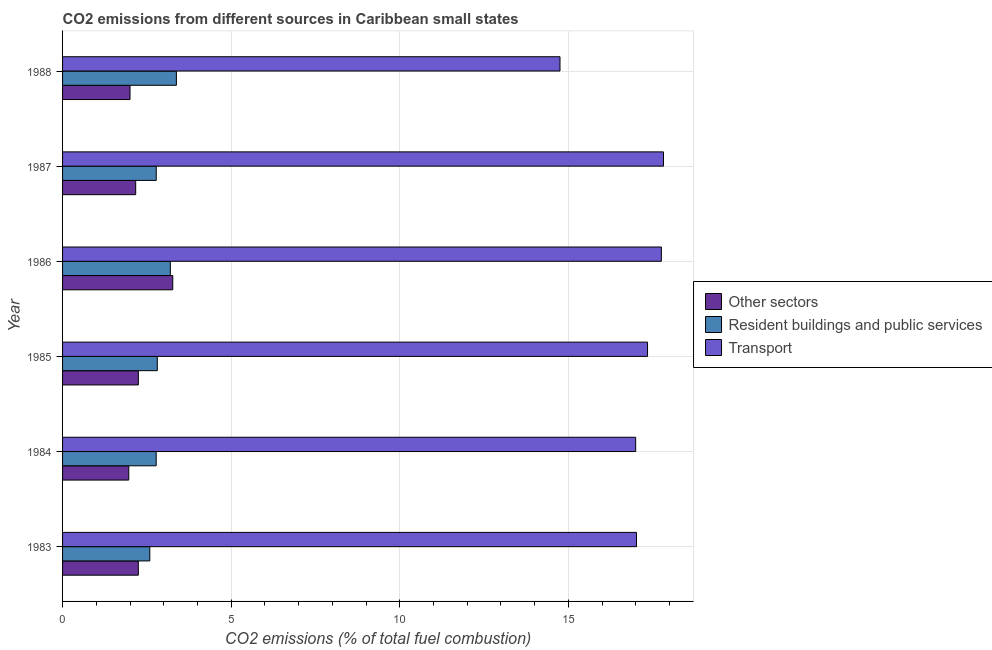How many groups of bars are there?
Your answer should be compact. 6. Are the number of bars per tick equal to the number of legend labels?
Provide a short and direct response. Yes. Are the number of bars on each tick of the Y-axis equal?
Keep it short and to the point. Yes. How many bars are there on the 2nd tick from the top?
Keep it short and to the point. 3. What is the percentage of co2 emissions from transport in 1988?
Your response must be concise. 14.75. Across all years, what is the maximum percentage of co2 emissions from other sectors?
Make the answer very short. 3.27. Across all years, what is the minimum percentage of co2 emissions from other sectors?
Make the answer very short. 1.96. In which year was the percentage of co2 emissions from resident buildings and public services maximum?
Your answer should be very brief. 1988. What is the total percentage of co2 emissions from other sectors in the graph?
Offer a very short reply. 13.89. What is the difference between the percentage of co2 emissions from other sectors in 1983 and that in 1984?
Ensure brevity in your answer.  0.28. What is the difference between the percentage of co2 emissions from other sectors in 1988 and the percentage of co2 emissions from resident buildings and public services in 1983?
Provide a short and direct response. -0.59. What is the average percentage of co2 emissions from other sectors per year?
Offer a terse response. 2.31. In the year 1988, what is the difference between the percentage of co2 emissions from resident buildings and public services and percentage of co2 emissions from transport?
Your answer should be very brief. -11.38. What is the ratio of the percentage of co2 emissions from resident buildings and public services in 1983 to that in 1988?
Give a very brief answer. 0.77. Is the percentage of co2 emissions from other sectors in 1983 less than that in 1986?
Offer a terse response. Yes. Is the difference between the percentage of co2 emissions from resident buildings and public services in 1983 and 1985 greater than the difference between the percentage of co2 emissions from other sectors in 1983 and 1985?
Provide a succinct answer. No. What is the difference between the highest and the second highest percentage of co2 emissions from resident buildings and public services?
Provide a short and direct response. 0.18. What does the 3rd bar from the top in 1984 represents?
Your answer should be very brief. Other sectors. What does the 1st bar from the bottom in 1986 represents?
Your answer should be very brief. Other sectors. Is it the case that in every year, the sum of the percentage of co2 emissions from other sectors and percentage of co2 emissions from resident buildings and public services is greater than the percentage of co2 emissions from transport?
Ensure brevity in your answer.  No. How many bars are there?
Your answer should be compact. 18. Are all the bars in the graph horizontal?
Your answer should be compact. Yes. What is the difference between two consecutive major ticks on the X-axis?
Your response must be concise. 5. How are the legend labels stacked?
Keep it short and to the point. Vertical. What is the title of the graph?
Offer a very short reply. CO2 emissions from different sources in Caribbean small states. Does "Ages 0-14" appear as one of the legend labels in the graph?
Your response must be concise. No. What is the label or title of the X-axis?
Give a very brief answer. CO2 emissions (% of total fuel combustion). What is the CO2 emissions (% of total fuel combustion) of Other sectors in 1983?
Provide a succinct answer. 2.25. What is the CO2 emissions (% of total fuel combustion) in Resident buildings and public services in 1983?
Your response must be concise. 2.59. What is the CO2 emissions (% of total fuel combustion) in Transport in 1983?
Provide a short and direct response. 17.02. What is the CO2 emissions (% of total fuel combustion) in Other sectors in 1984?
Your response must be concise. 1.96. What is the CO2 emissions (% of total fuel combustion) in Resident buildings and public services in 1984?
Make the answer very short. 2.78. What is the CO2 emissions (% of total fuel combustion) in Transport in 1984?
Provide a succinct answer. 16.99. What is the CO2 emissions (% of total fuel combustion) in Other sectors in 1985?
Give a very brief answer. 2.25. What is the CO2 emissions (% of total fuel combustion) in Resident buildings and public services in 1985?
Provide a succinct answer. 2.81. What is the CO2 emissions (% of total fuel combustion) in Transport in 1985?
Provide a succinct answer. 17.35. What is the CO2 emissions (% of total fuel combustion) of Other sectors in 1986?
Your answer should be compact. 3.27. What is the CO2 emissions (% of total fuel combustion) of Resident buildings and public services in 1986?
Ensure brevity in your answer.  3.2. What is the CO2 emissions (% of total fuel combustion) in Transport in 1986?
Your answer should be very brief. 17.76. What is the CO2 emissions (% of total fuel combustion) of Other sectors in 1987?
Make the answer very short. 2.17. What is the CO2 emissions (% of total fuel combustion) in Resident buildings and public services in 1987?
Keep it short and to the point. 2.78. What is the CO2 emissions (% of total fuel combustion) in Transport in 1987?
Keep it short and to the point. 17.82. What is the CO2 emissions (% of total fuel combustion) in Resident buildings and public services in 1988?
Your response must be concise. 3.38. What is the CO2 emissions (% of total fuel combustion) in Transport in 1988?
Offer a very short reply. 14.75. Across all years, what is the maximum CO2 emissions (% of total fuel combustion) in Other sectors?
Your answer should be compact. 3.27. Across all years, what is the maximum CO2 emissions (% of total fuel combustion) of Resident buildings and public services?
Provide a short and direct response. 3.38. Across all years, what is the maximum CO2 emissions (% of total fuel combustion) in Transport?
Your answer should be compact. 17.82. Across all years, what is the minimum CO2 emissions (% of total fuel combustion) of Other sectors?
Offer a very short reply. 1.96. Across all years, what is the minimum CO2 emissions (% of total fuel combustion) of Resident buildings and public services?
Your response must be concise. 2.59. Across all years, what is the minimum CO2 emissions (% of total fuel combustion) of Transport?
Give a very brief answer. 14.75. What is the total CO2 emissions (% of total fuel combustion) of Other sectors in the graph?
Provide a short and direct response. 13.89. What is the total CO2 emissions (% of total fuel combustion) of Resident buildings and public services in the graph?
Your response must be concise. 17.52. What is the total CO2 emissions (% of total fuel combustion) in Transport in the graph?
Offer a very short reply. 101.68. What is the difference between the CO2 emissions (% of total fuel combustion) of Other sectors in 1983 and that in 1984?
Offer a very short reply. 0.28. What is the difference between the CO2 emissions (% of total fuel combustion) in Resident buildings and public services in 1983 and that in 1984?
Offer a terse response. -0.19. What is the difference between the CO2 emissions (% of total fuel combustion) in Transport in 1983 and that in 1984?
Give a very brief answer. 0.02. What is the difference between the CO2 emissions (% of total fuel combustion) of Other sectors in 1983 and that in 1985?
Provide a succinct answer. -0. What is the difference between the CO2 emissions (% of total fuel combustion) of Resident buildings and public services in 1983 and that in 1985?
Give a very brief answer. -0.22. What is the difference between the CO2 emissions (% of total fuel combustion) in Transport in 1983 and that in 1985?
Provide a short and direct response. -0.33. What is the difference between the CO2 emissions (% of total fuel combustion) of Other sectors in 1983 and that in 1986?
Ensure brevity in your answer.  -1.02. What is the difference between the CO2 emissions (% of total fuel combustion) of Resident buildings and public services in 1983 and that in 1986?
Offer a terse response. -0.61. What is the difference between the CO2 emissions (% of total fuel combustion) of Transport in 1983 and that in 1986?
Offer a terse response. -0.74. What is the difference between the CO2 emissions (% of total fuel combustion) in Other sectors in 1983 and that in 1987?
Your response must be concise. 0.08. What is the difference between the CO2 emissions (% of total fuel combustion) in Resident buildings and public services in 1983 and that in 1987?
Provide a succinct answer. -0.19. What is the difference between the CO2 emissions (% of total fuel combustion) of Other sectors in 1983 and that in 1988?
Keep it short and to the point. 0.25. What is the difference between the CO2 emissions (% of total fuel combustion) of Resident buildings and public services in 1983 and that in 1988?
Make the answer very short. -0.79. What is the difference between the CO2 emissions (% of total fuel combustion) in Transport in 1983 and that in 1988?
Your answer should be compact. 2.27. What is the difference between the CO2 emissions (% of total fuel combustion) of Other sectors in 1984 and that in 1985?
Offer a very short reply. -0.28. What is the difference between the CO2 emissions (% of total fuel combustion) of Resident buildings and public services in 1984 and that in 1985?
Offer a terse response. -0.03. What is the difference between the CO2 emissions (% of total fuel combustion) in Transport in 1984 and that in 1985?
Your answer should be compact. -0.35. What is the difference between the CO2 emissions (% of total fuel combustion) of Other sectors in 1984 and that in 1986?
Keep it short and to the point. -1.3. What is the difference between the CO2 emissions (% of total fuel combustion) of Resident buildings and public services in 1984 and that in 1986?
Make the answer very short. -0.42. What is the difference between the CO2 emissions (% of total fuel combustion) in Transport in 1984 and that in 1986?
Provide a short and direct response. -0.76. What is the difference between the CO2 emissions (% of total fuel combustion) of Other sectors in 1984 and that in 1987?
Give a very brief answer. -0.2. What is the difference between the CO2 emissions (% of total fuel combustion) in Resident buildings and public services in 1984 and that in 1987?
Provide a short and direct response. -0. What is the difference between the CO2 emissions (% of total fuel combustion) in Transport in 1984 and that in 1987?
Your answer should be compact. -0.82. What is the difference between the CO2 emissions (% of total fuel combustion) of Other sectors in 1984 and that in 1988?
Ensure brevity in your answer.  -0.04. What is the difference between the CO2 emissions (% of total fuel combustion) of Resident buildings and public services in 1984 and that in 1988?
Offer a very short reply. -0.6. What is the difference between the CO2 emissions (% of total fuel combustion) in Transport in 1984 and that in 1988?
Offer a very short reply. 2.24. What is the difference between the CO2 emissions (% of total fuel combustion) in Other sectors in 1985 and that in 1986?
Offer a terse response. -1.02. What is the difference between the CO2 emissions (% of total fuel combustion) of Resident buildings and public services in 1985 and that in 1986?
Provide a succinct answer. -0.39. What is the difference between the CO2 emissions (% of total fuel combustion) of Transport in 1985 and that in 1986?
Ensure brevity in your answer.  -0.41. What is the difference between the CO2 emissions (% of total fuel combustion) in Other sectors in 1985 and that in 1987?
Provide a succinct answer. 0.08. What is the difference between the CO2 emissions (% of total fuel combustion) of Resident buildings and public services in 1985 and that in 1987?
Make the answer very short. 0.03. What is the difference between the CO2 emissions (% of total fuel combustion) in Transport in 1985 and that in 1987?
Keep it short and to the point. -0.47. What is the difference between the CO2 emissions (% of total fuel combustion) of Other sectors in 1985 and that in 1988?
Provide a succinct answer. 0.25. What is the difference between the CO2 emissions (% of total fuel combustion) of Resident buildings and public services in 1985 and that in 1988?
Provide a succinct answer. -0.57. What is the difference between the CO2 emissions (% of total fuel combustion) of Transport in 1985 and that in 1988?
Offer a very short reply. 2.6. What is the difference between the CO2 emissions (% of total fuel combustion) in Other sectors in 1986 and that in 1987?
Provide a short and direct response. 1.1. What is the difference between the CO2 emissions (% of total fuel combustion) in Resident buildings and public services in 1986 and that in 1987?
Provide a short and direct response. 0.42. What is the difference between the CO2 emissions (% of total fuel combustion) in Transport in 1986 and that in 1987?
Offer a very short reply. -0.06. What is the difference between the CO2 emissions (% of total fuel combustion) in Other sectors in 1986 and that in 1988?
Offer a terse response. 1.27. What is the difference between the CO2 emissions (% of total fuel combustion) in Resident buildings and public services in 1986 and that in 1988?
Provide a short and direct response. -0.18. What is the difference between the CO2 emissions (% of total fuel combustion) in Transport in 1986 and that in 1988?
Make the answer very short. 3.01. What is the difference between the CO2 emissions (% of total fuel combustion) in Other sectors in 1987 and that in 1988?
Provide a succinct answer. 0.17. What is the difference between the CO2 emissions (% of total fuel combustion) in Resident buildings and public services in 1987 and that in 1988?
Keep it short and to the point. -0.6. What is the difference between the CO2 emissions (% of total fuel combustion) of Transport in 1987 and that in 1988?
Make the answer very short. 3.07. What is the difference between the CO2 emissions (% of total fuel combustion) in Other sectors in 1983 and the CO2 emissions (% of total fuel combustion) in Resident buildings and public services in 1984?
Provide a short and direct response. -0.53. What is the difference between the CO2 emissions (% of total fuel combustion) in Other sectors in 1983 and the CO2 emissions (% of total fuel combustion) in Transport in 1984?
Offer a terse response. -14.75. What is the difference between the CO2 emissions (% of total fuel combustion) of Resident buildings and public services in 1983 and the CO2 emissions (% of total fuel combustion) of Transport in 1984?
Your answer should be compact. -14.41. What is the difference between the CO2 emissions (% of total fuel combustion) of Other sectors in 1983 and the CO2 emissions (% of total fuel combustion) of Resident buildings and public services in 1985?
Your response must be concise. -0.56. What is the difference between the CO2 emissions (% of total fuel combustion) in Other sectors in 1983 and the CO2 emissions (% of total fuel combustion) in Transport in 1985?
Offer a terse response. -15.1. What is the difference between the CO2 emissions (% of total fuel combustion) of Resident buildings and public services in 1983 and the CO2 emissions (% of total fuel combustion) of Transport in 1985?
Offer a terse response. -14.76. What is the difference between the CO2 emissions (% of total fuel combustion) in Other sectors in 1983 and the CO2 emissions (% of total fuel combustion) in Resident buildings and public services in 1986?
Provide a succinct answer. -0.95. What is the difference between the CO2 emissions (% of total fuel combustion) of Other sectors in 1983 and the CO2 emissions (% of total fuel combustion) of Transport in 1986?
Offer a very short reply. -15.51. What is the difference between the CO2 emissions (% of total fuel combustion) of Resident buildings and public services in 1983 and the CO2 emissions (% of total fuel combustion) of Transport in 1986?
Give a very brief answer. -15.17. What is the difference between the CO2 emissions (% of total fuel combustion) of Other sectors in 1983 and the CO2 emissions (% of total fuel combustion) of Resident buildings and public services in 1987?
Give a very brief answer. -0.53. What is the difference between the CO2 emissions (% of total fuel combustion) in Other sectors in 1983 and the CO2 emissions (% of total fuel combustion) in Transport in 1987?
Keep it short and to the point. -15.57. What is the difference between the CO2 emissions (% of total fuel combustion) of Resident buildings and public services in 1983 and the CO2 emissions (% of total fuel combustion) of Transport in 1987?
Offer a very short reply. -15.23. What is the difference between the CO2 emissions (% of total fuel combustion) in Other sectors in 1983 and the CO2 emissions (% of total fuel combustion) in Resident buildings and public services in 1988?
Your answer should be compact. -1.13. What is the difference between the CO2 emissions (% of total fuel combustion) of Other sectors in 1983 and the CO2 emissions (% of total fuel combustion) of Transport in 1988?
Your answer should be compact. -12.5. What is the difference between the CO2 emissions (% of total fuel combustion) in Resident buildings and public services in 1983 and the CO2 emissions (% of total fuel combustion) in Transport in 1988?
Offer a terse response. -12.16. What is the difference between the CO2 emissions (% of total fuel combustion) of Other sectors in 1984 and the CO2 emissions (% of total fuel combustion) of Resident buildings and public services in 1985?
Make the answer very short. -0.85. What is the difference between the CO2 emissions (% of total fuel combustion) in Other sectors in 1984 and the CO2 emissions (% of total fuel combustion) in Transport in 1985?
Provide a short and direct response. -15.38. What is the difference between the CO2 emissions (% of total fuel combustion) in Resident buildings and public services in 1984 and the CO2 emissions (% of total fuel combustion) in Transport in 1985?
Your answer should be compact. -14.57. What is the difference between the CO2 emissions (% of total fuel combustion) of Other sectors in 1984 and the CO2 emissions (% of total fuel combustion) of Resident buildings and public services in 1986?
Your answer should be very brief. -1.23. What is the difference between the CO2 emissions (% of total fuel combustion) in Other sectors in 1984 and the CO2 emissions (% of total fuel combustion) in Transport in 1986?
Your answer should be compact. -15.79. What is the difference between the CO2 emissions (% of total fuel combustion) of Resident buildings and public services in 1984 and the CO2 emissions (% of total fuel combustion) of Transport in 1986?
Ensure brevity in your answer.  -14.98. What is the difference between the CO2 emissions (% of total fuel combustion) in Other sectors in 1984 and the CO2 emissions (% of total fuel combustion) in Resident buildings and public services in 1987?
Keep it short and to the point. -0.81. What is the difference between the CO2 emissions (% of total fuel combustion) in Other sectors in 1984 and the CO2 emissions (% of total fuel combustion) in Transport in 1987?
Give a very brief answer. -15.86. What is the difference between the CO2 emissions (% of total fuel combustion) in Resident buildings and public services in 1984 and the CO2 emissions (% of total fuel combustion) in Transport in 1987?
Provide a succinct answer. -15.04. What is the difference between the CO2 emissions (% of total fuel combustion) in Other sectors in 1984 and the CO2 emissions (% of total fuel combustion) in Resident buildings and public services in 1988?
Give a very brief answer. -1.41. What is the difference between the CO2 emissions (% of total fuel combustion) of Other sectors in 1984 and the CO2 emissions (% of total fuel combustion) of Transport in 1988?
Keep it short and to the point. -12.79. What is the difference between the CO2 emissions (% of total fuel combustion) in Resident buildings and public services in 1984 and the CO2 emissions (% of total fuel combustion) in Transport in 1988?
Provide a succinct answer. -11.97. What is the difference between the CO2 emissions (% of total fuel combustion) of Other sectors in 1985 and the CO2 emissions (% of total fuel combustion) of Resident buildings and public services in 1986?
Provide a short and direct response. -0.95. What is the difference between the CO2 emissions (% of total fuel combustion) in Other sectors in 1985 and the CO2 emissions (% of total fuel combustion) in Transport in 1986?
Offer a very short reply. -15.51. What is the difference between the CO2 emissions (% of total fuel combustion) in Resident buildings and public services in 1985 and the CO2 emissions (% of total fuel combustion) in Transport in 1986?
Offer a terse response. -14.95. What is the difference between the CO2 emissions (% of total fuel combustion) in Other sectors in 1985 and the CO2 emissions (% of total fuel combustion) in Resident buildings and public services in 1987?
Offer a very short reply. -0.53. What is the difference between the CO2 emissions (% of total fuel combustion) of Other sectors in 1985 and the CO2 emissions (% of total fuel combustion) of Transport in 1987?
Your answer should be very brief. -15.57. What is the difference between the CO2 emissions (% of total fuel combustion) of Resident buildings and public services in 1985 and the CO2 emissions (% of total fuel combustion) of Transport in 1987?
Ensure brevity in your answer.  -15.01. What is the difference between the CO2 emissions (% of total fuel combustion) in Other sectors in 1985 and the CO2 emissions (% of total fuel combustion) in Resident buildings and public services in 1988?
Make the answer very short. -1.13. What is the difference between the CO2 emissions (% of total fuel combustion) of Other sectors in 1985 and the CO2 emissions (% of total fuel combustion) of Transport in 1988?
Ensure brevity in your answer.  -12.5. What is the difference between the CO2 emissions (% of total fuel combustion) in Resident buildings and public services in 1985 and the CO2 emissions (% of total fuel combustion) in Transport in 1988?
Make the answer very short. -11.94. What is the difference between the CO2 emissions (% of total fuel combustion) in Other sectors in 1986 and the CO2 emissions (% of total fuel combustion) in Resident buildings and public services in 1987?
Make the answer very short. 0.49. What is the difference between the CO2 emissions (% of total fuel combustion) of Other sectors in 1986 and the CO2 emissions (% of total fuel combustion) of Transport in 1987?
Provide a succinct answer. -14.55. What is the difference between the CO2 emissions (% of total fuel combustion) of Resident buildings and public services in 1986 and the CO2 emissions (% of total fuel combustion) of Transport in 1987?
Ensure brevity in your answer.  -14.62. What is the difference between the CO2 emissions (% of total fuel combustion) in Other sectors in 1986 and the CO2 emissions (% of total fuel combustion) in Resident buildings and public services in 1988?
Provide a succinct answer. -0.11. What is the difference between the CO2 emissions (% of total fuel combustion) of Other sectors in 1986 and the CO2 emissions (% of total fuel combustion) of Transport in 1988?
Give a very brief answer. -11.48. What is the difference between the CO2 emissions (% of total fuel combustion) in Resident buildings and public services in 1986 and the CO2 emissions (% of total fuel combustion) in Transport in 1988?
Keep it short and to the point. -11.55. What is the difference between the CO2 emissions (% of total fuel combustion) in Other sectors in 1987 and the CO2 emissions (% of total fuel combustion) in Resident buildings and public services in 1988?
Keep it short and to the point. -1.21. What is the difference between the CO2 emissions (% of total fuel combustion) of Other sectors in 1987 and the CO2 emissions (% of total fuel combustion) of Transport in 1988?
Ensure brevity in your answer.  -12.58. What is the difference between the CO2 emissions (% of total fuel combustion) in Resident buildings and public services in 1987 and the CO2 emissions (% of total fuel combustion) in Transport in 1988?
Keep it short and to the point. -11.97. What is the average CO2 emissions (% of total fuel combustion) in Other sectors per year?
Your answer should be compact. 2.32. What is the average CO2 emissions (% of total fuel combustion) of Resident buildings and public services per year?
Make the answer very short. 2.92. What is the average CO2 emissions (% of total fuel combustion) in Transport per year?
Your answer should be very brief. 16.95. In the year 1983, what is the difference between the CO2 emissions (% of total fuel combustion) of Other sectors and CO2 emissions (% of total fuel combustion) of Resident buildings and public services?
Make the answer very short. -0.34. In the year 1983, what is the difference between the CO2 emissions (% of total fuel combustion) in Other sectors and CO2 emissions (% of total fuel combustion) in Transport?
Provide a succinct answer. -14.77. In the year 1983, what is the difference between the CO2 emissions (% of total fuel combustion) of Resident buildings and public services and CO2 emissions (% of total fuel combustion) of Transport?
Offer a terse response. -14.43. In the year 1984, what is the difference between the CO2 emissions (% of total fuel combustion) of Other sectors and CO2 emissions (% of total fuel combustion) of Resident buildings and public services?
Offer a terse response. -0.81. In the year 1984, what is the difference between the CO2 emissions (% of total fuel combustion) of Other sectors and CO2 emissions (% of total fuel combustion) of Transport?
Offer a very short reply. -15.03. In the year 1984, what is the difference between the CO2 emissions (% of total fuel combustion) in Resident buildings and public services and CO2 emissions (% of total fuel combustion) in Transport?
Your response must be concise. -14.22. In the year 1985, what is the difference between the CO2 emissions (% of total fuel combustion) of Other sectors and CO2 emissions (% of total fuel combustion) of Resident buildings and public services?
Your answer should be very brief. -0.56. In the year 1985, what is the difference between the CO2 emissions (% of total fuel combustion) in Other sectors and CO2 emissions (% of total fuel combustion) in Transport?
Give a very brief answer. -15.1. In the year 1985, what is the difference between the CO2 emissions (% of total fuel combustion) in Resident buildings and public services and CO2 emissions (% of total fuel combustion) in Transport?
Keep it short and to the point. -14.54. In the year 1986, what is the difference between the CO2 emissions (% of total fuel combustion) in Other sectors and CO2 emissions (% of total fuel combustion) in Resident buildings and public services?
Your response must be concise. 0.07. In the year 1986, what is the difference between the CO2 emissions (% of total fuel combustion) of Other sectors and CO2 emissions (% of total fuel combustion) of Transport?
Provide a short and direct response. -14.49. In the year 1986, what is the difference between the CO2 emissions (% of total fuel combustion) in Resident buildings and public services and CO2 emissions (% of total fuel combustion) in Transport?
Provide a short and direct response. -14.56. In the year 1987, what is the difference between the CO2 emissions (% of total fuel combustion) of Other sectors and CO2 emissions (% of total fuel combustion) of Resident buildings and public services?
Your response must be concise. -0.61. In the year 1987, what is the difference between the CO2 emissions (% of total fuel combustion) of Other sectors and CO2 emissions (% of total fuel combustion) of Transport?
Offer a very short reply. -15.65. In the year 1987, what is the difference between the CO2 emissions (% of total fuel combustion) in Resident buildings and public services and CO2 emissions (% of total fuel combustion) in Transport?
Ensure brevity in your answer.  -15.04. In the year 1988, what is the difference between the CO2 emissions (% of total fuel combustion) of Other sectors and CO2 emissions (% of total fuel combustion) of Resident buildings and public services?
Make the answer very short. -1.38. In the year 1988, what is the difference between the CO2 emissions (% of total fuel combustion) in Other sectors and CO2 emissions (% of total fuel combustion) in Transport?
Make the answer very short. -12.75. In the year 1988, what is the difference between the CO2 emissions (% of total fuel combustion) in Resident buildings and public services and CO2 emissions (% of total fuel combustion) in Transport?
Keep it short and to the point. -11.38. What is the ratio of the CO2 emissions (% of total fuel combustion) in Other sectors in 1983 to that in 1984?
Make the answer very short. 1.14. What is the ratio of the CO2 emissions (% of total fuel combustion) of Resident buildings and public services in 1983 to that in 1984?
Your answer should be very brief. 0.93. What is the ratio of the CO2 emissions (% of total fuel combustion) of Transport in 1983 to that in 1984?
Make the answer very short. 1. What is the ratio of the CO2 emissions (% of total fuel combustion) of Resident buildings and public services in 1983 to that in 1985?
Your response must be concise. 0.92. What is the ratio of the CO2 emissions (% of total fuel combustion) of Transport in 1983 to that in 1985?
Your answer should be very brief. 0.98. What is the ratio of the CO2 emissions (% of total fuel combustion) in Other sectors in 1983 to that in 1986?
Provide a short and direct response. 0.69. What is the ratio of the CO2 emissions (% of total fuel combustion) of Resident buildings and public services in 1983 to that in 1986?
Your response must be concise. 0.81. What is the ratio of the CO2 emissions (% of total fuel combustion) in Transport in 1983 to that in 1986?
Your answer should be compact. 0.96. What is the ratio of the CO2 emissions (% of total fuel combustion) in Other sectors in 1983 to that in 1987?
Provide a succinct answer. 1.04. What is the ratio of the CO2 emissions (% of total fuel combustion) in Resident buildings and public services in 1983 to that in 1987?
Your answer should be very brief. 0.93. What is the ratio of the CO2 emissions (% of total fuel combustion) in Transport in 1983 to that in 1987?
Give a very brief answer. 0.96. What is the ratio of the CO2 emissions (% of total fuel combustion) in Other sectors in 1983 to that in 1988?
Make the answer very short. 1.12. What is the ratio of the CO2 emissions (% of total fuel combustion) in Resident buildings and public services in 1983 to that in 1988?
Your answer should be compact. 0.77. What is the ratio of the CO2 emissions (% of total fuel combustion) in Transport in 1983 to that in 1988?
Make the answer very short. 1.15. What is the ratio of the CO2 emissions (% of total fuel combustion) in Other sectors in 1984 to that in 1985?
Your answer should be very brief. 0.87. What is the ratio of the CO2 emissions (% of total fuel combustion) of Transport in 1984 to that in 1985?
Offer a terse response. 0.98. What is the ratio of the CO2 emissions (% of total fuel combustion) of Other sectors in 1984 to that in 1986?
Make the answer very short. 0.6. What is the ratio of the CO2 emissions (% of total fuel combustion) of Resident buildings and public services in 1984 to that in 1986?
Make the answer very short. 0.87. What is the ratio of the CO2 emissions (% of total fuel combustion) in Transport in 1984 to that in 1986?
Your answer should be very brief. 0.96. What is the ratio of the CO2 emissions (% of total fuel combustion) of Other sectors in 1984 to that in 1987?
Offer a terse response. 0.91. What is the ratio of the CO2 emissions (% of total fuel combustion) of Resident buildings and public services in 1984 to that in 1987?
Your response must be concise. 1. What is the ratio of the CO2 emissions (% of total fuel combustion) in Transport in 1984 to that in 1987?
Your response must be concise. 0.95. What is the ratio of the CO2 emissions (% of total fuel combustion) of Other sectors in 1984 to that in 1988?
Your answer should be compact. 0.98. What is the ratio of the CO2 emissions (% of total fuel combustion) in Resident buildings and public services in 1984 to that in 1988?
Offer a very short reply. 0.82. What is the ratio of the CO2 emissions (% of total fuel combustion) of Transport in 1984 to that in 1988?
Provide a short and direct response. 1.15. What is the ratio of the CO2 emissions (% of total fuel combustion) of Other sectors in 1985 to that in 1986?
Your response must be concise. 0.69. What is the ratio of the CO2 emissions (% of total fuel combustion) in Resident buildings and public services in 1985 to that in 1986?
Offer a terse response. 0.88. What is the ratio of the CO2 emissions (% of total fuel combustion) in Transport in 1985 to that in 1986?
Provide a succinct answer. 0.98. What is the ratio of the CO2 emissions (% of total fuel combustion) in Other sectors in 1985 to that in 1987?
Offer a very short reply. 1.04. What is the ratio of the CO2 emissions (% of total fuel combustion) in Resident buildings and public services in 1985 to that in 1987?
Make the answer very short. 1.01. What is the ratio of the CO2 emissions (% of total fuel combustion) in Transport in 1985 to that in 1987?
Ensure brevity in your answer.  0.97. What is the ratio of the CO2 emissions (% of total fuel combustion) in Other sectors in 1985 to that in 1988?
Your answer should be very brief. 1.12. What is the ratio of the CO2 emissions (% of total fuel combustion) of Resident buildings and public services in 1985 to that in 1988?
Offer a terse response. 0.83. What is the ratio of the CO2 emissions (% of total fuel combustion) in Transport in 1985 to that in 1988?
Keep it short and to the point. 1.18. What is the ratio of the CO2 emissions (% of total fuel combustion) in Other sectors in 1986 to that in 1987?
Your answer should be compact. 1.51. What is the ratio of the CO2 emissions (% of total fuel combustion) in Resident buildings and public services in 1986 to that in 1987?
Your response must be concise. 1.15. What is the ratio of the CO2 emissions (% of total fuel combustion) of Transport in 1986 to that in 1987?
Offer a very short reply. 1. What is the ratio of the CO2 emissions (% of total fuel combustion) of Other sectors in 1986 to that in 1988?
Give a very brief answer. 1.63. What is the ratio of the CO2 emissions (% of total fuel combustion) of Resident buildings and public services in 1986 to that in 1988?
Your response must be concise. 0.95. What is the ratio of the CO2 emissions (% of total fuel combustion) of Transport in 1986 to that in 1988?
Your response must be concise. 1.2. What is the ratio of the CO2 emissions (% of total fuel combustion) in Other sectors in 1987 to that in 1988?
Provide a short and direct response. 1.08. What is the ratio of the CO2 emissions (% of total fuel combustion) in Resident buildings and public services in 1987 to that in 1988?
Give a very brief answer. 0.82. What is the ratio of the CO2 emissions (% of total fuel combustion) of Transport in 1987 to that in 1988?
Offer a terse response. 1.21. What is the difference between the highest and the second highest CO2 emissions (% of total fuel combustion) in Other sectors?
Your response must be concise. 1.02. What is the difference between the highest and the second highest CO2 emissions (% of total fuel combustion) of Resident buildings and public services?
Offer a very short reply. 0.18. What is the difference between the highest and the second highest CO2 emissions (% of total fuel combustion) of Transport?
Make the answer very short. 0.06. What is the difference between the highest and the lowest CO2 emissions (% of total fuel combustion) in Other sectors?
Offer a terse response. 1.3. What is the difference between the highest and the lowest CO2 emissions (% of total fuel combustion) of Resident buildings and public services?
Ensure brevity in your answer.  0.79. What is the difference between the highest and the lowest CO2 emissions (% of total fuel combustion) in Transport?
Make the answer very short. 3.07. 